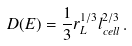Convert formula to latex. <formula><loc_0><loc_0><loc_500><loc_500>D ( E ) = \frac { 1 } { 3 } r _ { L } ^ { 1 / 3 } l _ { c e l l } ^ { 2 / 3 } \, .</formula> 